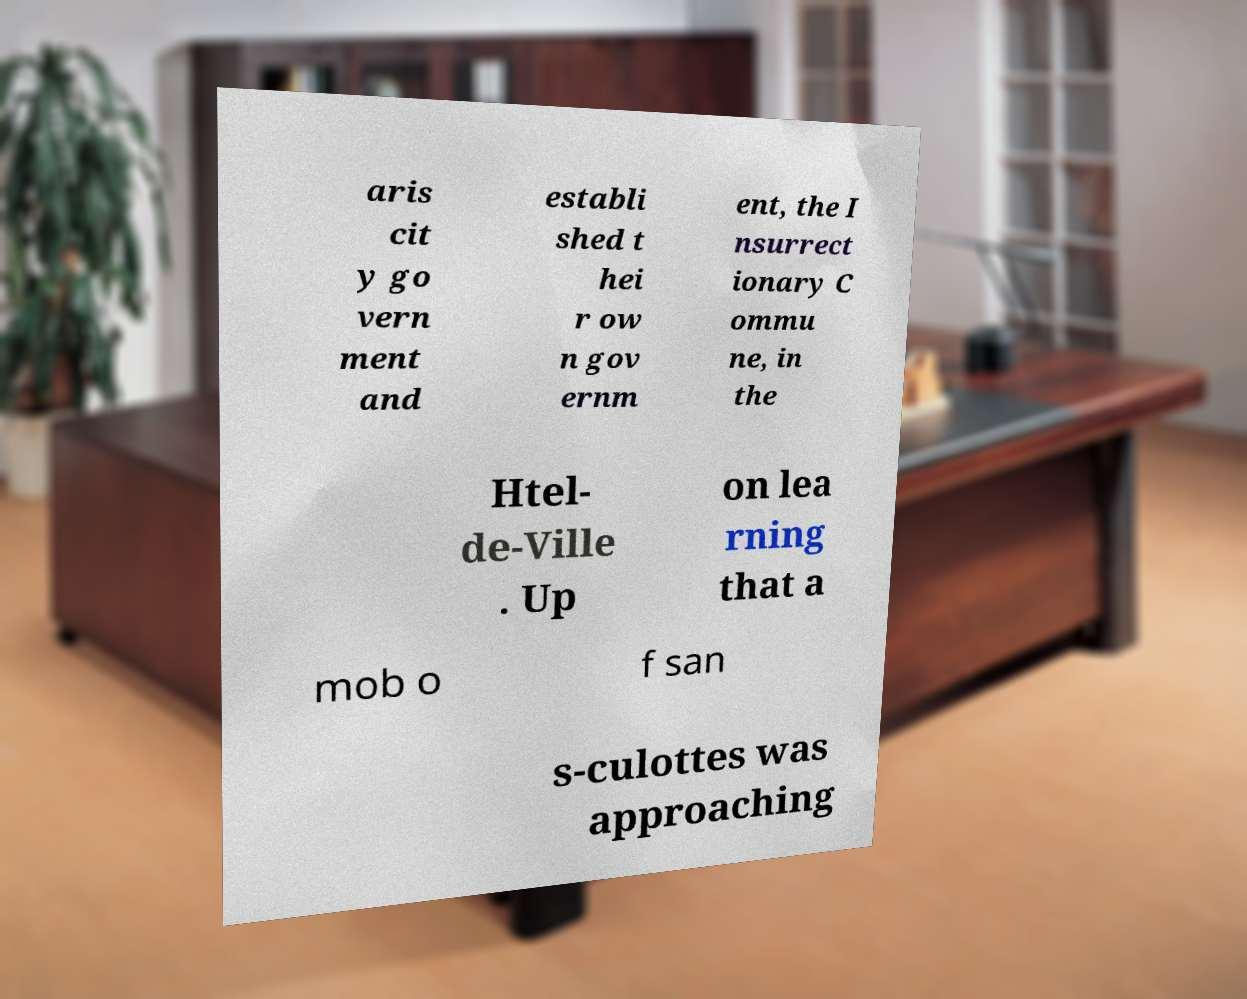Please identify and transcribe the text found in this image. aris cit y go vern ment and establi shed t hei r ow n gov ernm ent, the I nsurrect ionary C ommu ne, in the Htel- de-Ville . Up on lea rning that a mob o f san s-culottes was approaching 